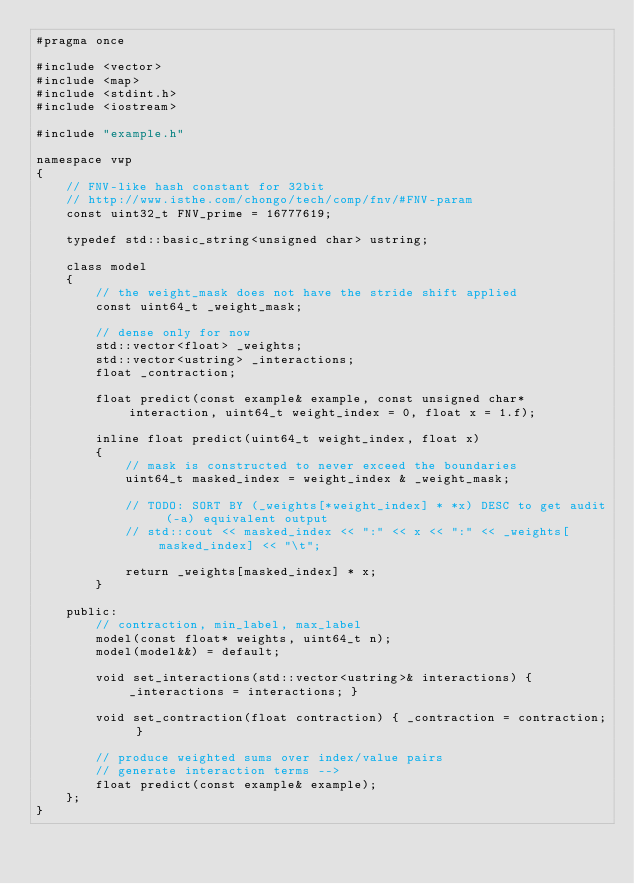<code> <loc_0><loc_0><loc_500><loc_500><_C_>#pragma once

#include <vector>
#include <map>
#include <stdint.h>
#include <iostream>

#include "example.h"

namespace vwp
{
    // FNV-like hash constant for 32bit
    // http://www.isthe.com/chongo/tech/comp/fnv/#FNV-param
    const uint32_t FNV_prime = 16777619;

    typedef std::basic_string<unsigned char> ustring;

    class model
    {
        // the weight_mask does not have the stride shift applied
        const uint64_t _weight_mask;

        // dense only for now
        std::vector<float> _weights;
        std::vector<ustring> _interactions;
        float _contraction;

        float predict(const example& example, const unsigned char* interaction, uint64_t weight_index = 0, float x = 1.f);
        
        inline float predict(uint64_t weight_index, float x)
        { 
            // mask is constructed to never exceed the boundaries
            uint64_t masked_index = weight_index & _weight_mask;

            // TODO: SORT BY (_weights[*weight_index] * *x) DESC to get audit (-a) equivalent output
            // std::cout << masked_index << ":" << x << ":" << _weights[masked_index] << "\t";

            return _weights[masked_index] * x;
        }

    public:
        // contraction, min_label, max_label
        model(const float* weights, uint64_t n);
        model(model&&) = default;

        void set_interactions(std::vector<ustring>& interactions) { _interactions = interactions; }

        void set_contraction(float contraction) { _contraction = contraction; }

        // produce weighted sums over index/value pairs
        // generate interaction terms --> 
        float predict(const example& example);
    };
}</code> 